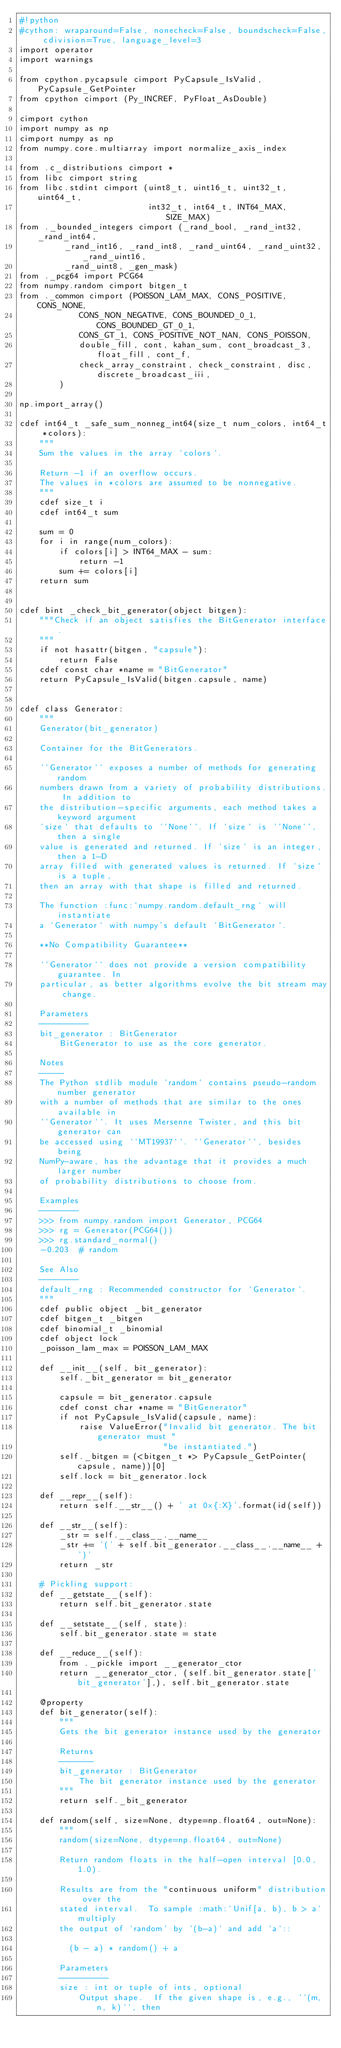<code> <loc_0><loc_0><loc_500><loc_500><_Cython_>#!python
#cython: wraparound=False, nonecheck=False, boundscheck=False, cdivision=True, language_level=3
import operator
import warnings

from cpython.pycapsule cimport PyCapsule_IsValid, PyCapsule_GetPointer
from cpython cimport (Py_INCREF, PyFloat_AsDouble)

cimport cython
import numpy as np
cimport numpy as np
from numpy.core.multiarray import normalize_axis_index

from .c_distributions cimport *
from libc cimport string
from libc.stdint cimport (uint8_t, uint16_t, uint32_t, uint64_t,
                          int32_t, int64_t, INT64_MAX, SIZE_MAX)
from ._bounded_integers cimport (_rand_bool, _rand_int32, _rand_int64,
         _rand_int16, _rand_int8, _rand_uint64, _rand_uint32, _rand_uint16,
         _rand_uint8, _gen_mask)
from ._pcg64 import PCG64
from numpy.random cimport bitgen_t
from ._common cimport (POISSON_LAM_MAX, CONS_POSITIVE, CONS_NONE,
            CONS_NON_NEGATIVE, CONS_BOUNDED_0_1, CONS_BOUNDED_GT_0_1,
            CONS_GT_1, CONS_POSITIVE_NOT_NAN, CONS_POISSON,
            double_fill, cont, kahan_sum, cont_broadcast_3, float_fill, cont_f,
            check_array_constraint, check_constraint, disc, discrete_broadcast_iii,
        )

np.import_array()

cdef int64_t _safe_sum_nonneg_int64(size_t num_colors, int64_t *colors):
    """
    Sum the values in the array `colors`.

    Return -1 if an overflow occurs.
    The values in *colors are assumed to be nonnegative.
    """
    cdef size_t i
    cdef int64_t sum

    sum = 0
    for i in range(num_colors):
        if colors[i] > INT64_MAX - sum:
            return -1
        sum += colors[i]
    return sum


cdef bint _check_bit_generator(object bitgen):
    """Check if an object satisfies the BitGenerator interface.
    """
    if not hasattr(bitgen, "capsule"):
        return False
    cdef const char *name = "BitGenerator"
    return PyCapsule_IsValid(bitgen.capsule, name)


cdef class Generator:
    """
    Generator(bit_generator)

    Container for the BitGenerators.

    ``Generator`` exposes a number of methods for generating random
    numbers drawn from a variety of probability distributions. In addition to
    the distribution-specific arguments, each method takes a keyword argument
    `size` that defaults to ``None``. If `size` is ``None``, then a single
    value is generated and returned. If `size` is an integer, then a 1-D
    array filled with generated values is returned. If `size` is a tuple,
    then an array with that shape is filled and returned.

    The function :func:`numpy.random.default_rng` will instantiate
    a `Generator` with numpy's default `BitGenerator`.

    **No Compatibility Guarantee**

    ``Generator`` does not provide a version compatibility guarantee. In
    particular, as better algorithms evolve the bit stream may change.

    Parameters
    ----------
    bit_generator : BitGenerator
        BitGenerator to use as the core generator.

    Notes
    -----
    The Python stdlib module `random` contains pseudo-random number generator
    with a number of methods that are similar to the ones available in
    ``Generator``. It uses Mersenne Twister, and this bit generator can
    be accessed using ``MT19937``. ``Generator``, besides being
    NumPy-aware, has the advantage that it provides a much larger number
    of probability distributions to choose from.

    Examples
    --------
    >>> from numpy.random import Generator, PCG64
    >>> rg = Generator(PCG64())
    >>> rg.standard_normal()
    -0.203  # random

    See Also
    --------
    default_rng : Recommended constructor for `Generator`.
    """
    cdef public object _bit_generator
    cdef bitgen_t _bitgen
    cdef binomial_t _binomial
    cdef object lock
    _poisson_lam_max = POISSON_LAM_MAX

    def __init__(self, bit_generator):
        self._bit_generator = bit_generator

        capsule = bit_generator.capsule
        cdef const char *name = "BitGenerator"
        if not PyCapsule_IsValid(capsule, name):
            raise ValueError("Invalid bit generator. The bit generator must "
                             "be instantiated.")
        self._bitgen = (<bitgen_t *> PyCapsule_GetPointer(capsule, name))[0]
        self.lock = bit_generator.lock

    def __repr__(self):
        return self.__str__() + ' at 0x{:X}'.format(id(self))

    def __str__(self):
        _str = self.__class__.__name__
        _str += '(' + self.bit_generator.__class__.__name__ + ')'
        return _str

    # Pickling support:
    def __getstate__(self):
        return self.bit_generator.state

    def __setstate__(self, state):
        self.bit_generator.state = state

    def __reduce__(self):
        from ._pickle import __generator_ctor
        return __generator_ctor, (self.bit_generator.state['bit_generator'],), self.bit_generator.state

    @property
    def bit_generator(self):
        """
        Gets the bit generator instance used by the generator

        Returns
        -------
        bit_generator : BitGenerator
            The bit generator instance used by the generator
        """
        return self._bit_generator

    def random(self, size=None, dtype=np.float64, out=None):
        """
        random(size=None, dtype=np.float64, out=None)

        Return random floats in the half-open interval [0.0, 1.0).

        Results are from the "continuous uniform" distribution over the
        stated interval.  To sample :math:`Unif[a, b), b > a` multiply
        the output of `random` by `(b-a)` and add `a`::

          (b - a) * random() + a

        Parameters
        ----------
        size : int or tuple of ints, optional
            Output shape.  If the given shape is, e.g., ``(m, n, k)``, then</code> 